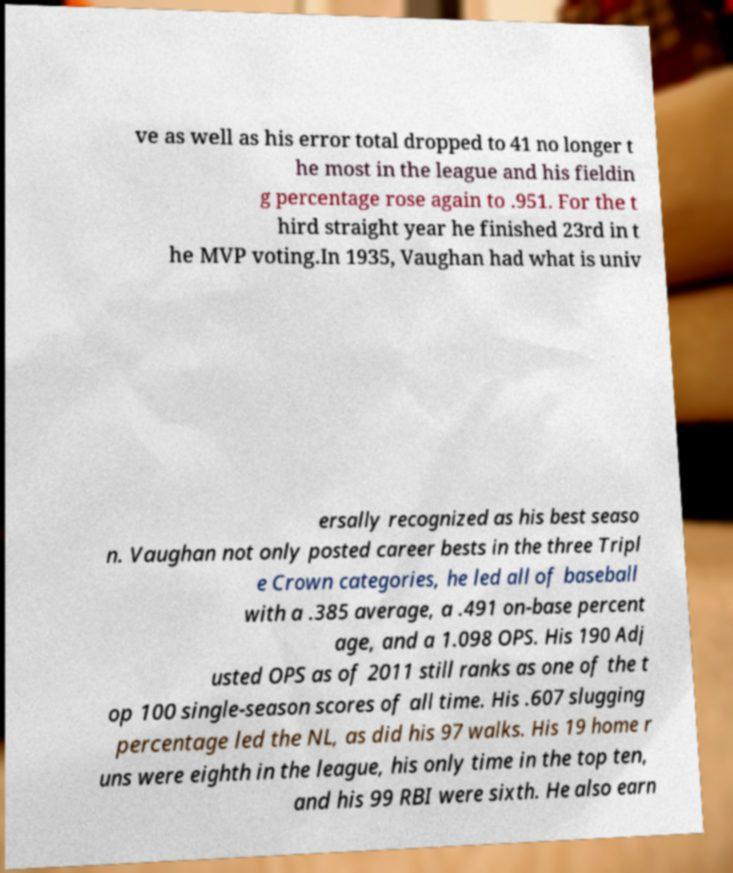Please read and relay the text visible in this image. What does it say? ve as well as his error total dropped to 41 no longer t he most in the league and his fieldin g percentage rose again to .951. For the t hird straight year he finished 23rd in t he MVP voting.In 1935, Vaughan had what is univ ersally recognized as his best seaso n. Vaughan not only posted career bests in the three Tripl e Crown categories, he led all of baseball with a .385 average, a .491 on-base percent age, and a 1.098 OPS. His 190 Adj usted OPS as of 2011 still ranks as one of the t op 100 single-season scores of all time. His .607 slugging percentage led the NL, as did his 97 walks. His 19 home r uns were eighth in the league, his only time in the top ten, and his 99 RBI were sixth. He also earn 